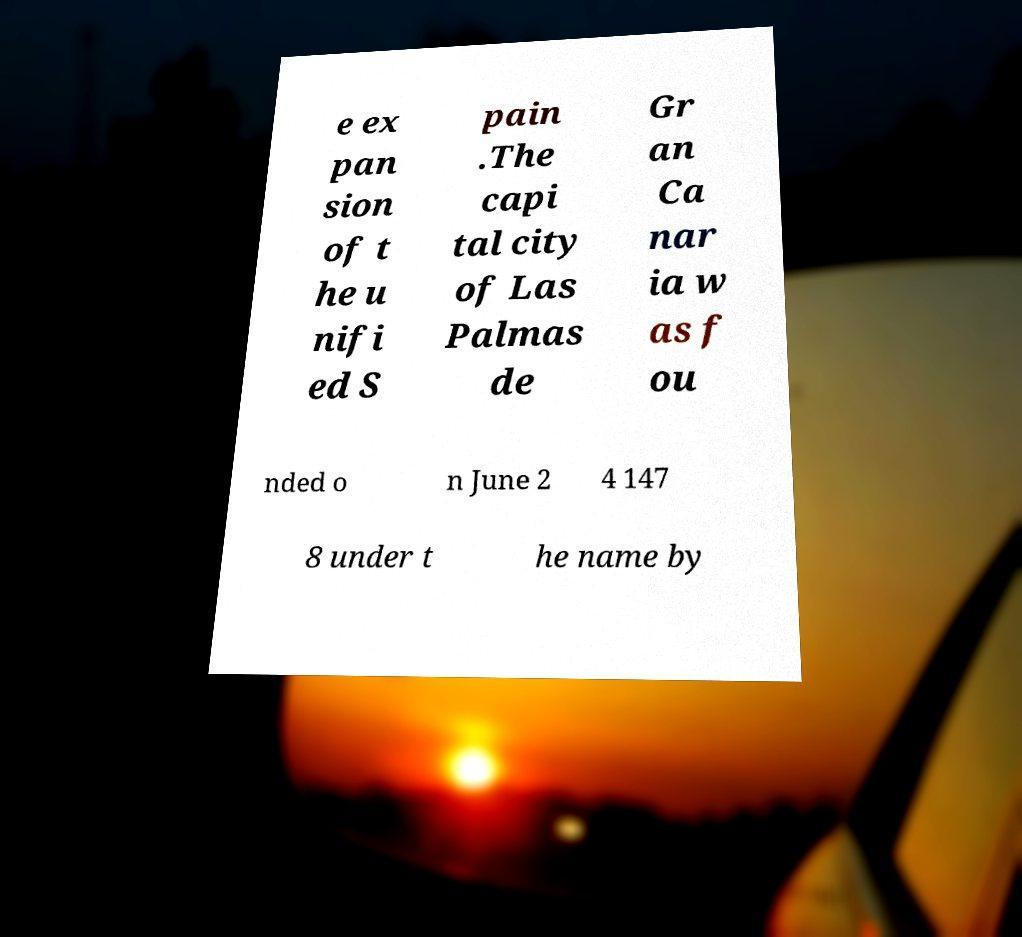Can you accurately transcribe the text from the provided image for me? e ex pan sion of t he u nifi ed S pain .The capi tal city of Las Palmas de Gr an Ca nar ia w as f ou nded o n June 2 4 147 8 under t he name by 